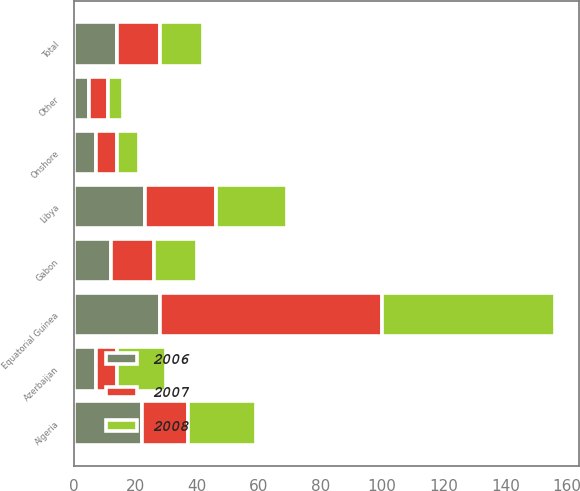Convert chart. <chart><loc_0><loc_0><loc_500><loc_500><stacked_bar_chart><ecel><fcel>Equatorial Guinea<fcel>Algeria<fcel>Gabon<fcel>Libya<fcel>Azerbaijan<fcel>Other<fcel>Total<fcel>Onshore<nl><fcel>2007<fcel>72<fcel>15<fcel>14<fcel>23<fcel>7<fcel>6<fcel>14<fcel>7<nl><fcel>2008<fcel>56<fcel>22<fcel>14<fcel>23<fcel>16<fcel>5<fcel>14<fcel>7<nl><fcel>2006<fcel>28<fcel>22<fcel>12<fcel>23<fcel>7<fcel>5<fcel>14<fcel>7<nl></chart> 